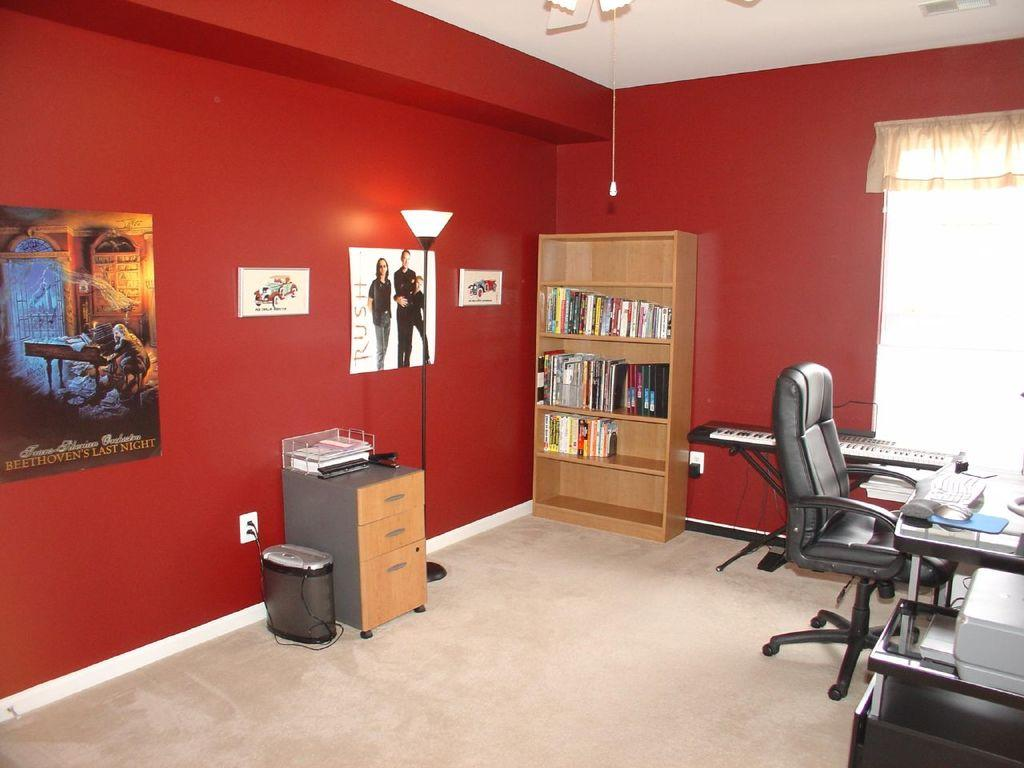What type of furniture is present in the image? There is a bookshelf, a table, and a chair in the image. What is attached to the wall in the image? There are photo frames attached to the wall in the image. Where is the piano located in the image? The piano is in the right corner of the image. What is the background of the image? There is a wall in the image. What type of crime is being committed in the image? There is no crime being committed in the image; it features a bookshelf, wall, photo frames, table, chair, and piano. What design elements are present in the image? The question is not relevant to the image, as it does not focus on any specific design elements. 